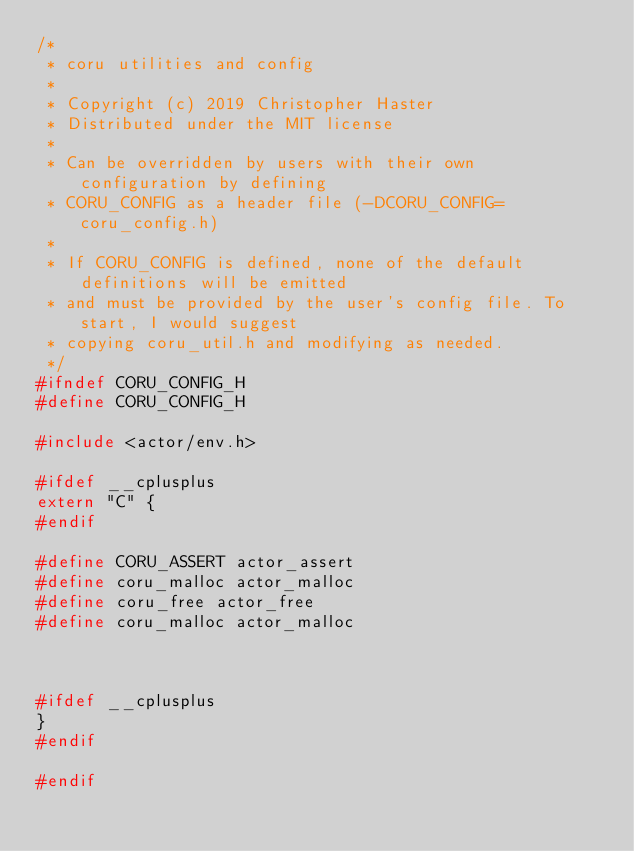Convert code to text. <code><loc_0><loc_0><loc_500><loc_500><_C_>/*
 * coru utilities and config
 *
 * Copyright (c) 2019 Christopher Haster
 * Distributed under the MIT license
 *
 * Can be overridden by users with their own configuration by defining
 * CORU_CONFIG as a header file (-DCORU_CONFIG=coru_config.h)
 *
 * If CORU_CONFIG is defined, none of the default definitions will be emitted
 * and must be provided by the user's config file. To start, I would suggest
 * copying coru_util.h and modifying as needed.
 */
#ifndef CORU_CONFIG_H
#define CORU_CONFIG_H

#include <actor/env.h>

#ifdef __cplusplus
extern "C" {
#endif

#define CORU_ASSERT actor_assert
#define coru_malloc actor_malloc
#define coru_free actor_free
#define coru_malloc actor_malloc



#ifdef __cplusplus
}
#endif

#endif
</code> 